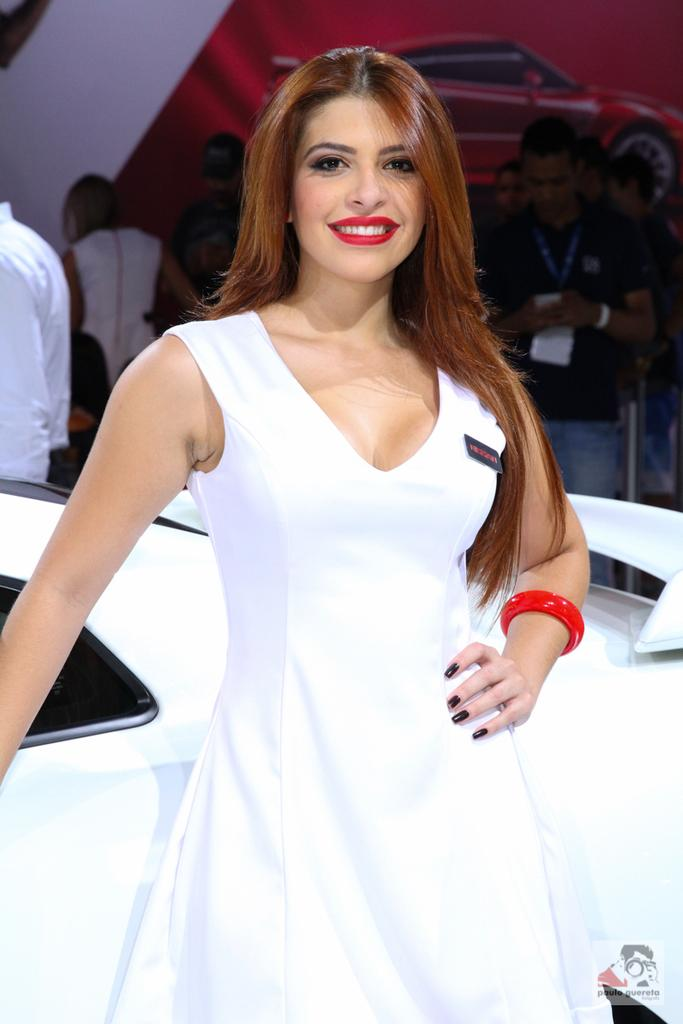What is the woman doing in the image? The woman is standing beside a car in the image. What are the other people in the image doing? There is a group of people standing on the backside of the car. Is there any other representation of a car in the image? Yes, there is a picture of a car on the surface (presumably on the ground or a wall). What type of rhythm can be heard coming from the car in the image? There is no sound or rhythm present in the image; it is a still picture. 